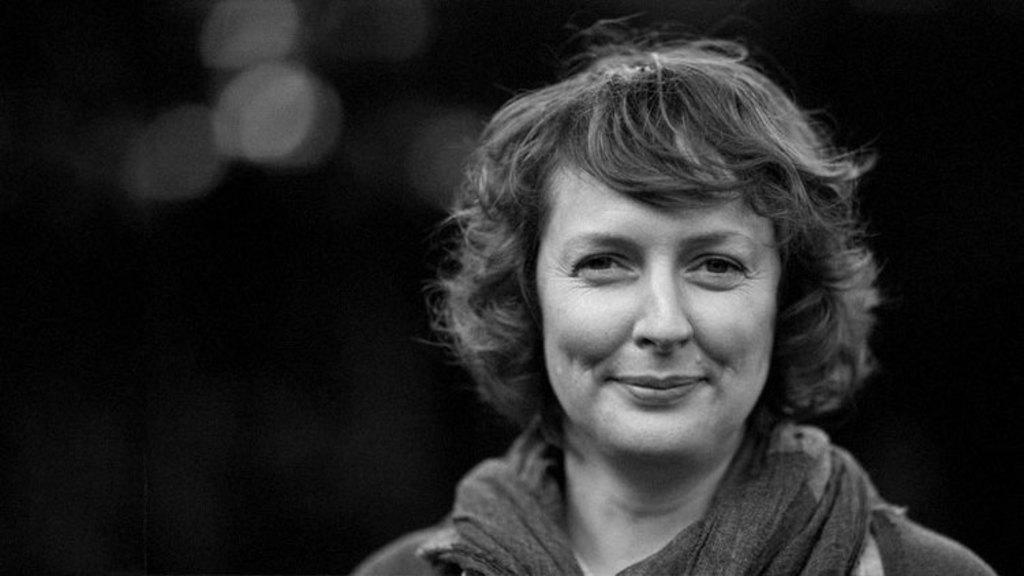What is the color scheme of the image? The image is black and white. Who is present in the image? There is a woman in the image. What is the woman's expression in the image? The woman is smiling in the image. What can be seen in the background of the image? The background of the image is dark. What type of jewel is the woman wearing in the image? There is no mention of a jewel in the image, so it cannot be determined if the woman is wearing one. 